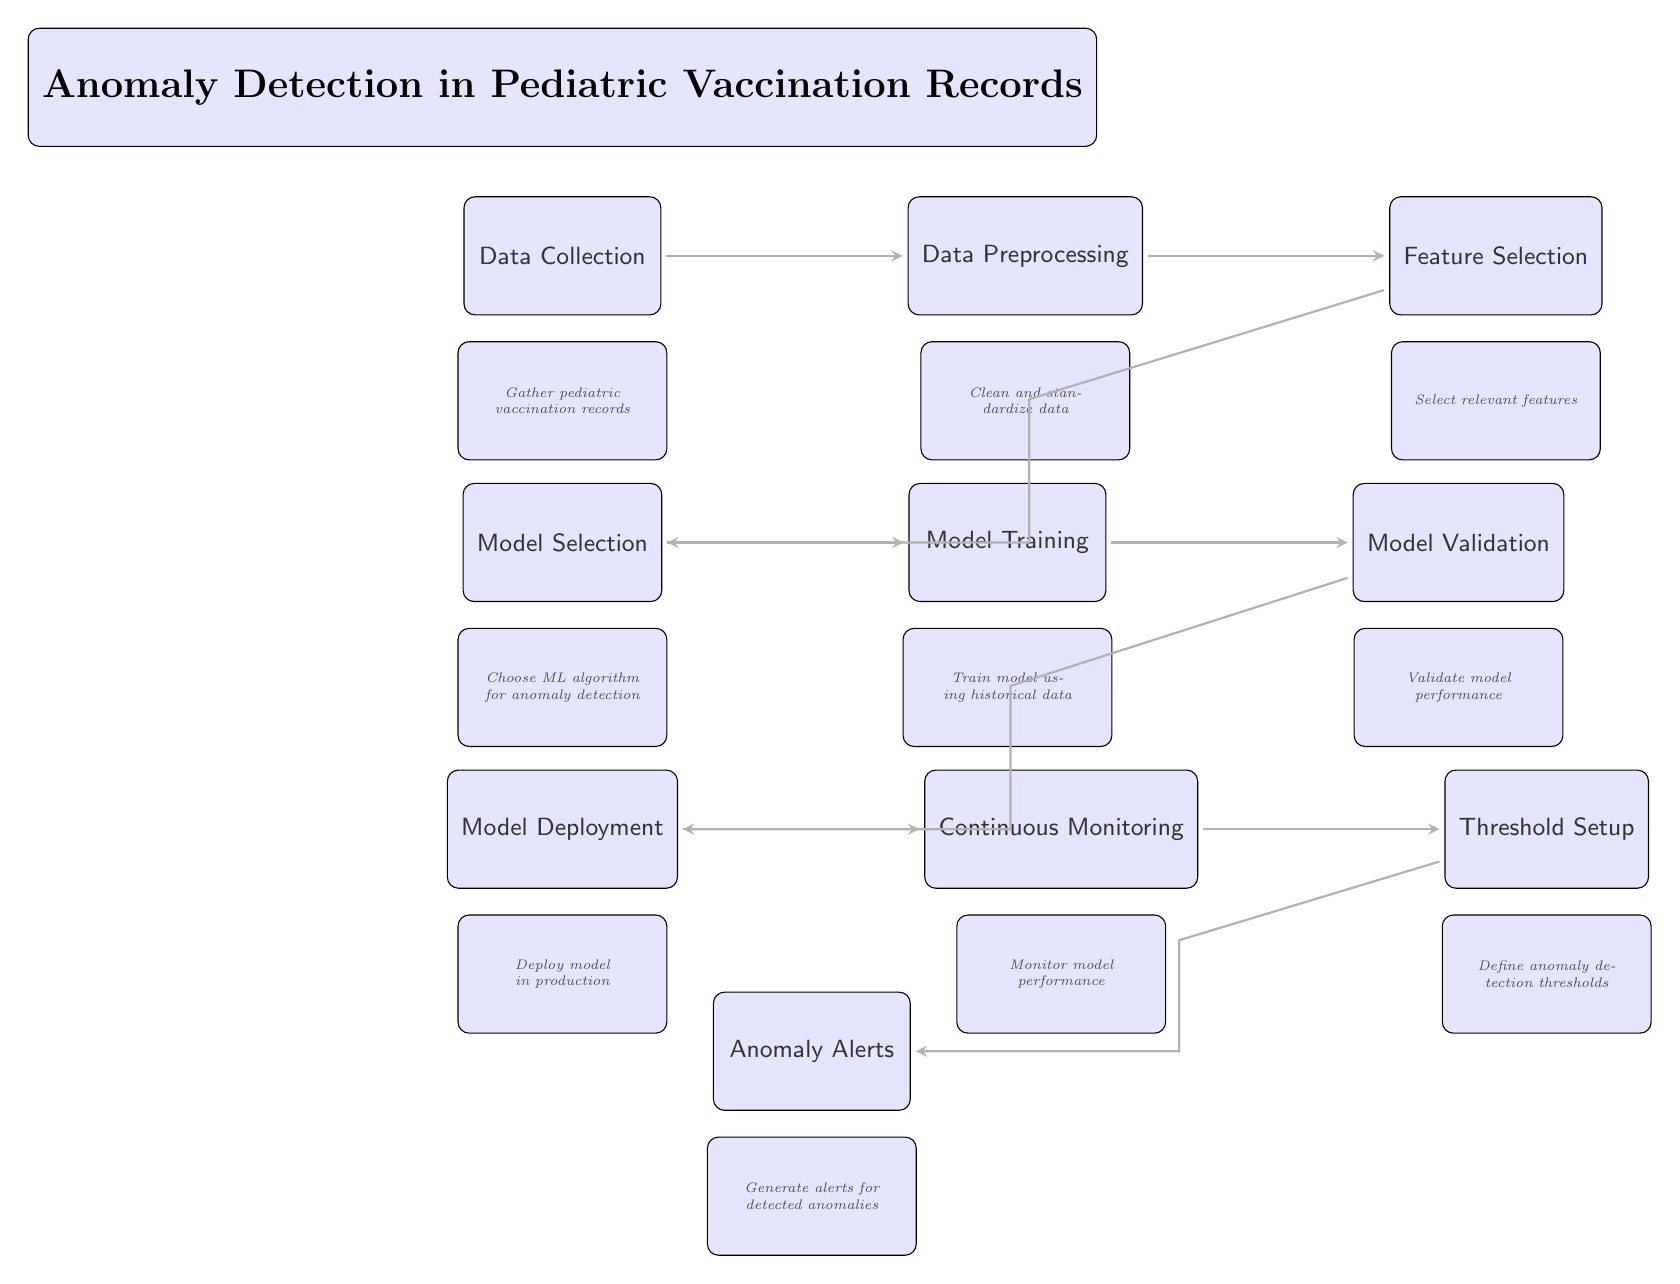What is the first step in the diagram? The first step in the diagram is labeled "Data Collection," which indicates that the initial action involves gathering pediatric vaccination records.
Answer: Data Collection How many main nodes are present in the diagram? By counting each main step represented as a node, there are a total of 9 main nodes in the diagram, including the title.
Answer: 9 What is the purpose of the "Model Validation" node? The "Model Validation" node is focused on validating the performance of the machine learning model after it has been trained, ensuring it works as expected.
Answer: Validate model performance Which node comes immediately after "Feature Selection"? The node that comes immediately after "Feature Selection" is "Model Selection," indicating that after selecting relevant features, the next step is to choose the appropriate ML algorithm for anomaly detection.
Answer: Model Selection What is the last node in the process? The last node in the diagram is "Anomaly Alerts," which generates alerts when anomalies are detected based on the thresholds defined earlier.
Answer: Anomaly Alerts What relationship exists between "Training" and "Validation"? "Training" directly leads to "Validation"; this means after the model is trained using historical data, it is evaluated for performance.
Answer: Direct relationship In which phase is the model deployed? The model is deployed during the "Model Deployment" phase, indicating that the model moves into production for practical use.
Answer: Model Deployment What occurs during "Continuous Monitoring"? During "Continuous Monitoring," the performance of the deployed model is closely observed to ensure it continues to function correctly and detect anomalies.
Answer: Monitor model performance What setup follows after "Continuous Monitoring"? The "Threshold Setup" node follows after "Continuous Monitoring," indicating the next step is to define thresholds for detecting anomalies.
Answer: Threshold Setup 